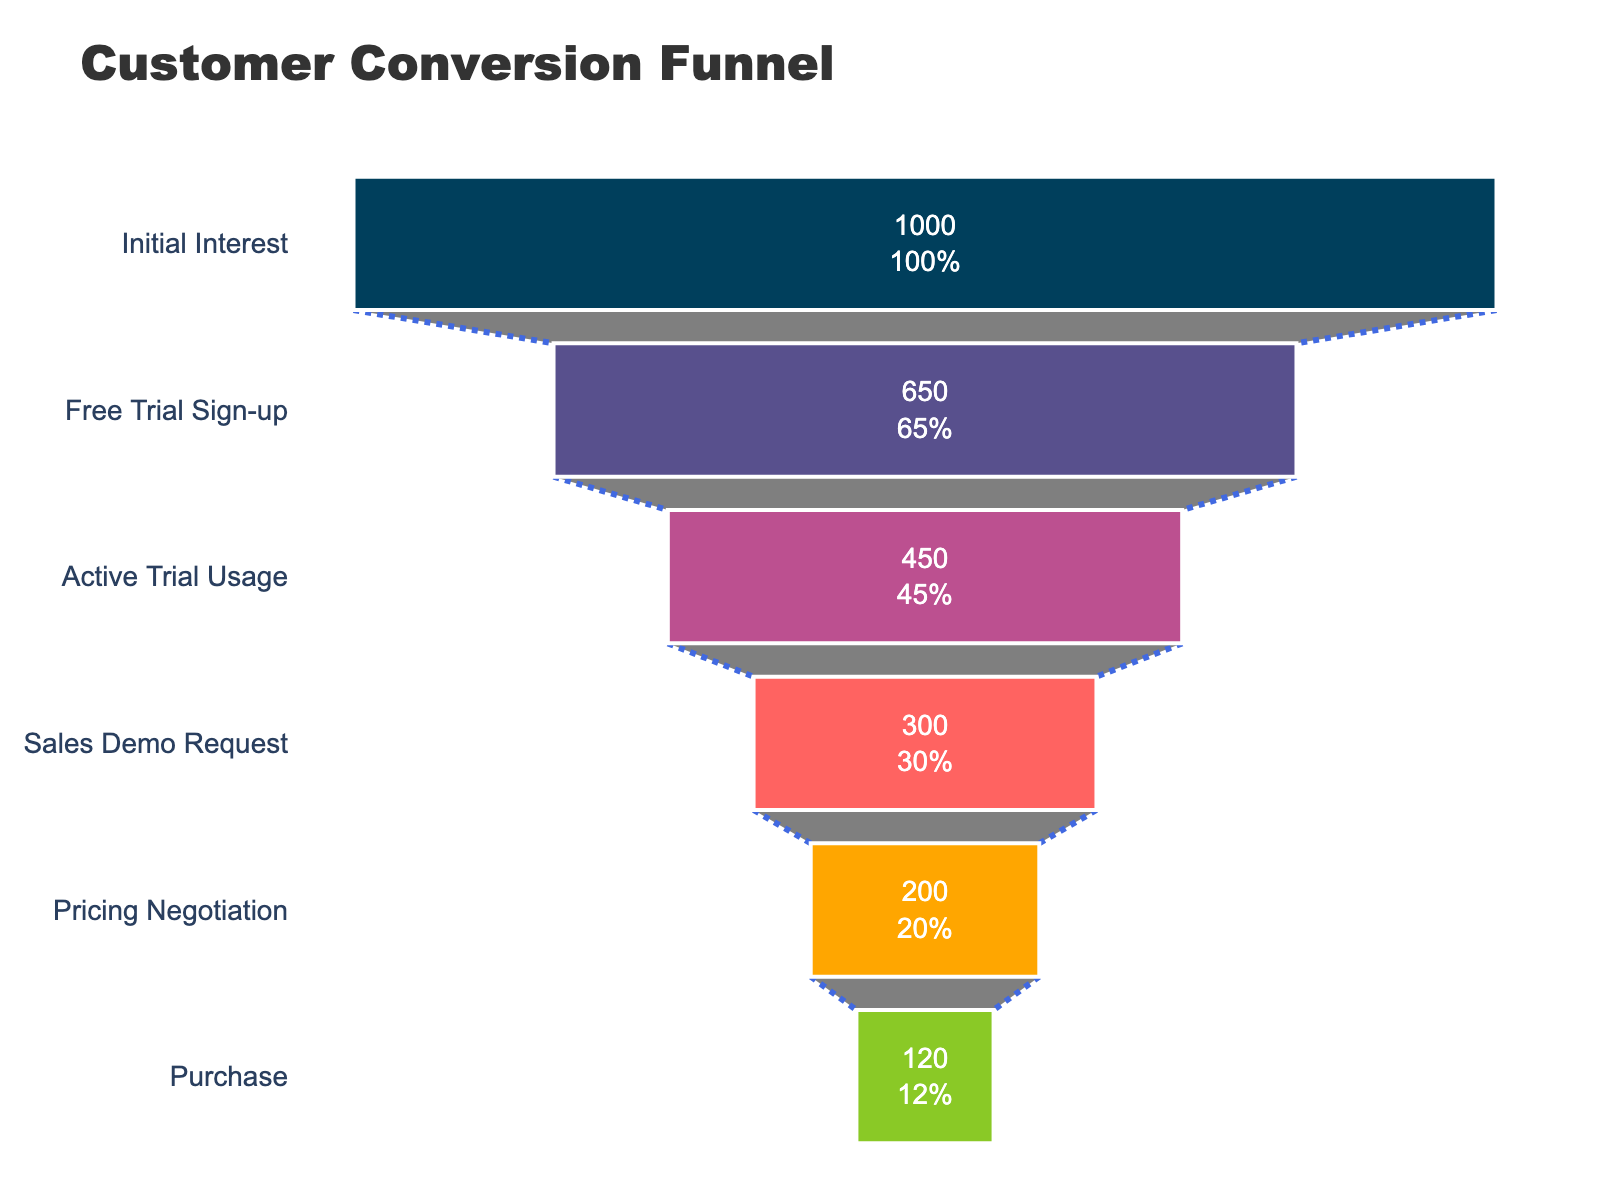What's the title of the funnel chart? The title of the chart is usually displayed prominently at the top of the figure. In this case, the title is "Customer Conversion Funnel", as specified in the code's layout settings.
Answer: Customer Conversion Funnel How many stages are there in the funnel? By counting the distinct colored segments in the funnel chart, we can see there are six stages: Initial Interest, Free Trial Sign-up, Active Trial Usage, Sales Demo Request, Pricing Negotiation, and Purchase.
Answer: 6 What is the percentage of people who signed up for a free trial? The figure shows a funnel segment labeled "Free Trial Sign-up", which is 65% of the initial interest.
Answer: 65% Which stage has the lowest percentage conversion rate? By looking at the funnel segments, the smallest one at the bottom represents the stage with the lowest percentage conversion rate, which is Purchase at 12%.
Answer: Purchase What is the difference in conversion rates between 'Active Trial Usage' and 'Sales Demo Request'? We need to find the percentage for 'Active Trial Usage' (45%) and 'Sales Demo Request' (30%), then subtract the latter from the former: 45% - 30% = 15%.
Answer: 15% How many people are at the Pricing Negotiation stage if the Initial Interest had 1000 people? First, compute the conversion from 1000 Initial Interests to Pricing Negotiation: 1000 * 20% = 200 people.
Answer: 200 Which stage has more conversions: 'Free Trial Sign-up' or 'Pricing Negotiation'? Comparing the percentages, 'Free Trial Sign-up' has 65% and 'Pricing Negotiation' has 20%. 65% is greater than 20%, so 'Free Trial Sign-up' has more conversions.
Answer: Free Trial Sign-up How does the conversion rate of 'Sales Demo Request' compare to 'Free Trial Sign-up'? The 'Sales Demo Request' has a 30% conversion rate and 'Free Trial Sign-up' has 65%. 30% is less than 65%.
Answer: Less than What percentage of those who requested a sales demo ended up purchasing? First, find the percentage of Sales Demo Requests (30%) and Purchases (12%), then calculate the proportion: (12% / 30%) * 100%. This equals 40%.
Answer: 40% What is the combined percentage of customers reaching either 'Pricing Negotiation' or 'Purchase'? Sum the percentages for Pricing Negotiation (20%) and Purchase (12%): 20% + 12% = 32%.
Answer: 32% 